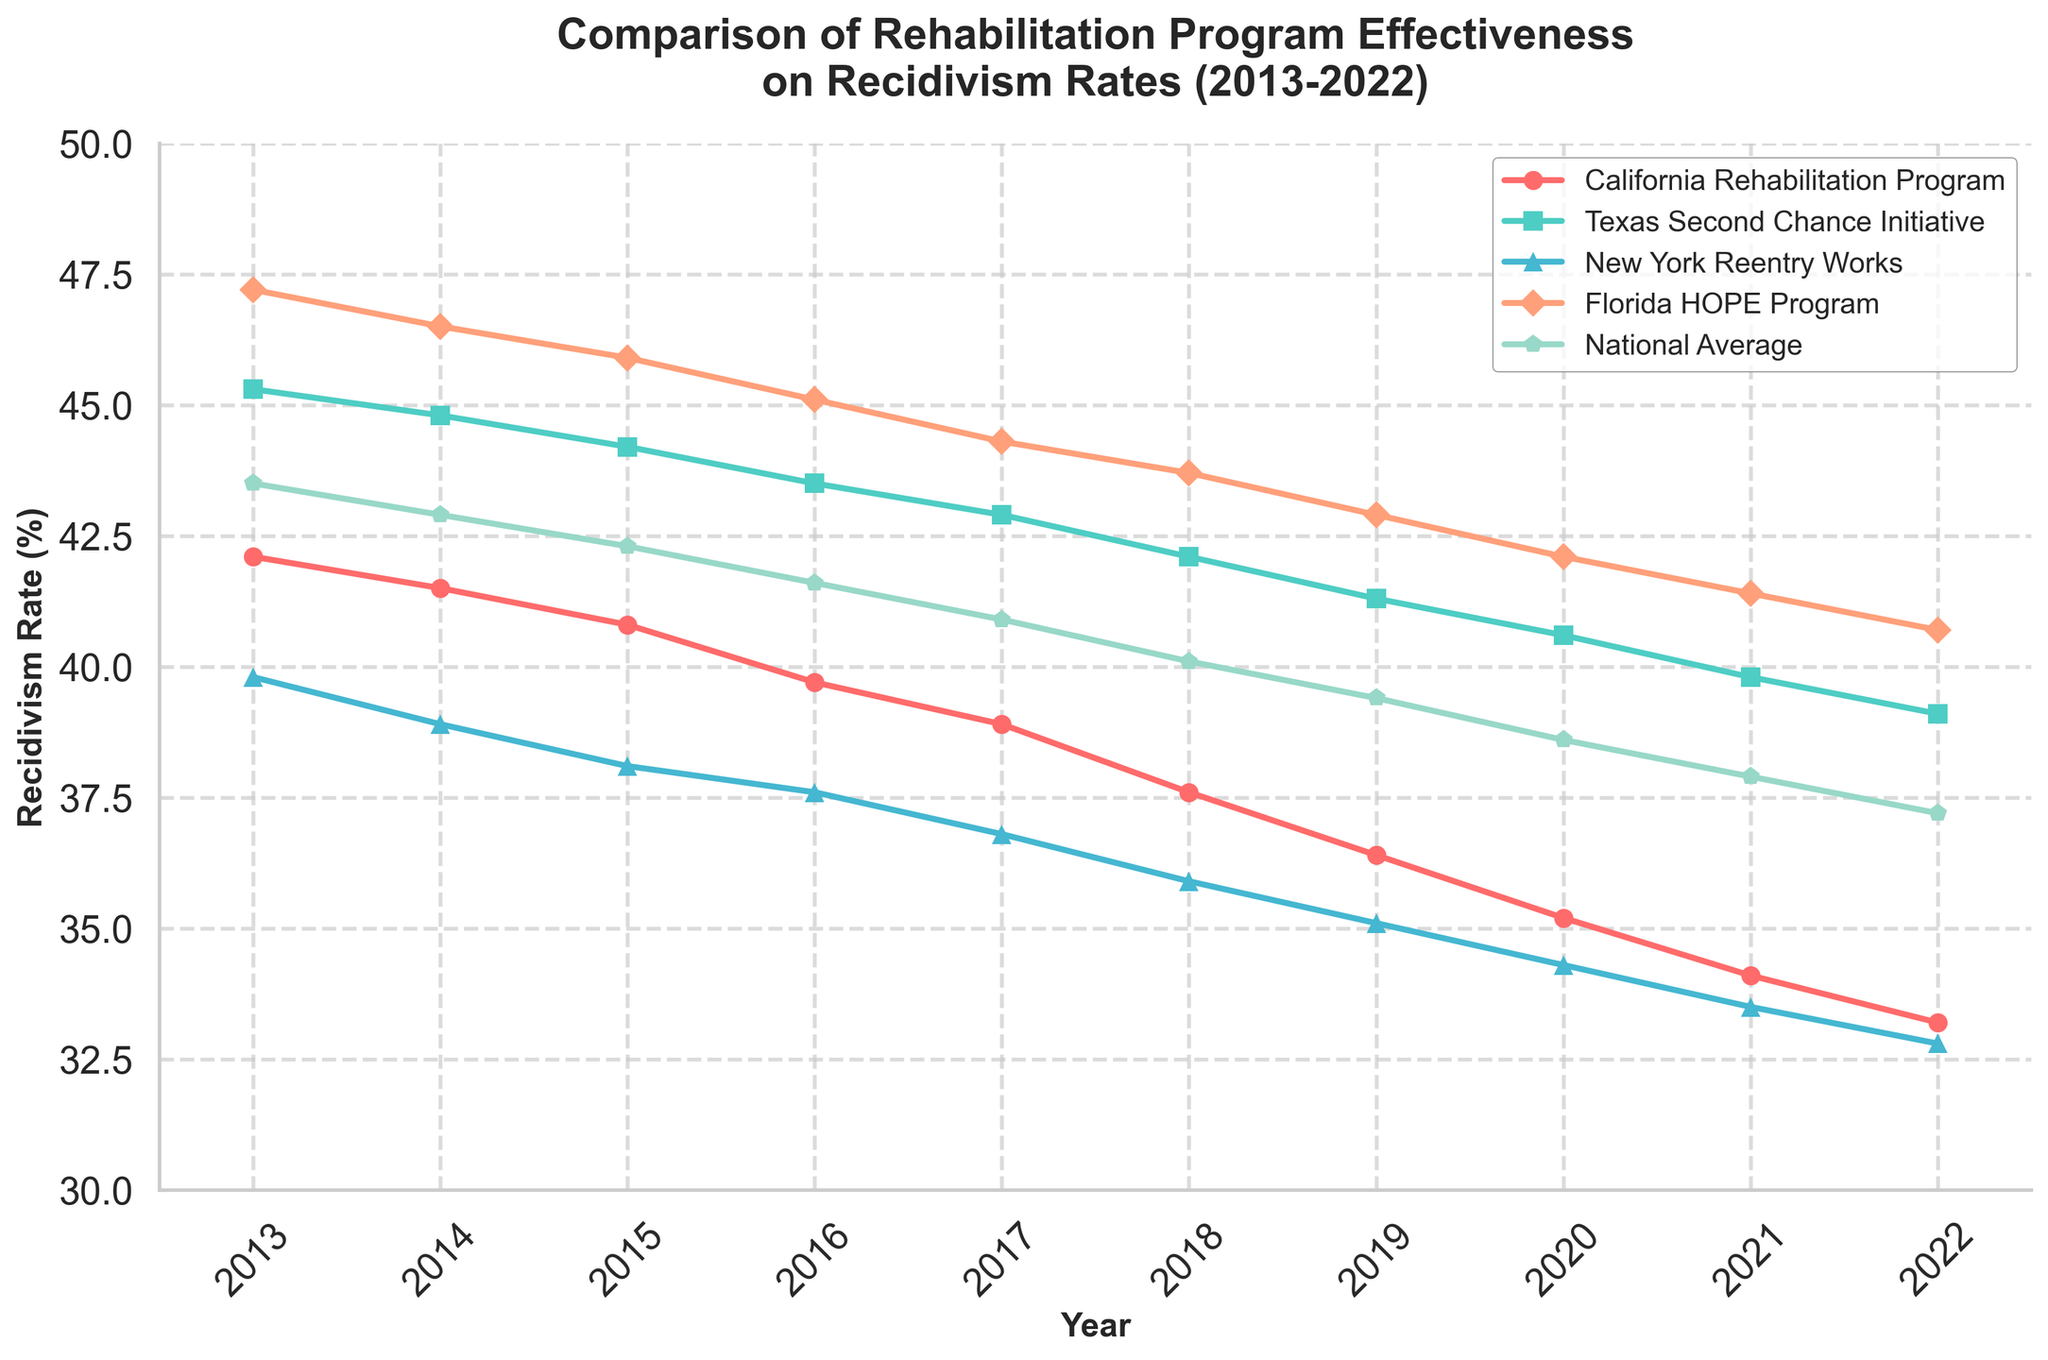How did the recidivism rate for the California Rehabilitation Program change from 2013 to 2022? From the figure, find the points for California Rehabilitation Program in 2013 and 2022. Subtract the value in 2022 (33.2) from the value in 2013 (42.1). This gives a decrease of 8.9.
Answer: The recidivism rate decreased by 8.9% Which state program had the highest recidivism rate in 2022? Look at the endpoints of all lines in 2022 and identify the highest value. The Florida HOPE Program had the highest rate of 40.7%.
Answer: Florida HOPE Program Compare the trend of recidivism rates for Texas Second Chance Initiative and New York Reentry Works over the 10-year period. Which one showed a more substantial decrease? Check the starting and ending points for both programs. Texas started at 45.3 in 2013 and ended at 39.1 in 2022 (decrease of 6.2). New York started at 39.8 in 2013 and ended at 32.8 in 2022 (decrease of 7.0). New York showed a more substantial decrease.
Answer: New York Reentry Works Which program shows the closest trend to the National Average from 2013 to 2022? Examine all program lines and compare their trends to the National Average line. Texas Second Chance Initiative seems to mirror the National Average most closely.
Answer: Texas Second Chance Initiative What is the average recidivism rate of Florida HOPE Program from 2013 to 2022? Sum up the recidivism rates for each year (47.2 + 46.5 + 45.9 + 45.1 + 44.3 + 43.7 + 42.9 + 42.1 + 41.4 + 40.7) = 439.8. Divide by the number of years (10).
Answer: 43.98% By how many percentage points did the National Average recidivism rate decrease from 2013 to 2019? Find the National Average value in 2013 (43.5) and in 2019 (39.4). Subtract the 2019 value from the 2013 value (43.5 - 39.4) = 4.1 percentage points.
Answer: 4.1 percentage points What is the difference in recidivism rates between the California Rehabilitation Program and the Florida HOPE Program in 2017? Find the values for both programs in 2017 (California: 38.9, Florida: 44.3). Subtract the California value from the Florida value (44.3 - 38.9).
Answer: 5.4 percentage points Which program had the lowest recidivism rate in 2020? Look at the values in 2020 for each program and identify the lowest one. The New York Reentry Works had the lowest rate with 34.3.
Answer: New York Reentry Works How did the recidivism rate of Texas Second Chance Initiative change from 2015 to 2018? Find the values for Texas Second Chance Initiative in 2015 (44.2) and in 2018 (42.1). Subtract the 2018 value from the 2015 value (44.2 - 42.1) = 2.1. The rate decreased by 2.1 percentage points.
Answer: Decreased by 2.1 percentage points 